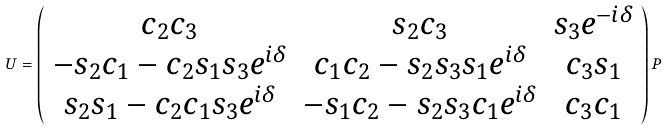Convert formula to latex. <formula><loc_0><loc_0><loc_500><loc_500>U = \left ( \begin{array} { c c c } c _ { 2 } c _ { 3 } & s _ { 2 } c _ { 3 } & s _ { 3 } e ^ { - i \delta } \\ - s _ { 2 } c _ { 1 } - c _ { 2 } s _ { 1 } s _ { 3 } e ^ { i \delta } & c _ { 1 } c _ { 2 } - s _ { 2 } s _ { 3 } s _ { 1 } e ^ { i \delta } & c _ { 3 } s _ { 1 } \\ s _ { 2 } s _ { 1 } - c _ { 2 } c _ { 1 } s _ { 3 } e ^ { i \delta } & - s _ { 1 } c _ { 2 } - s _ { 2 } s _ { 3 } c _ { 1 } e ^ { i \delta } & c _ { 3 } c _ { 1 } \end{array} \right ) P</formula> 